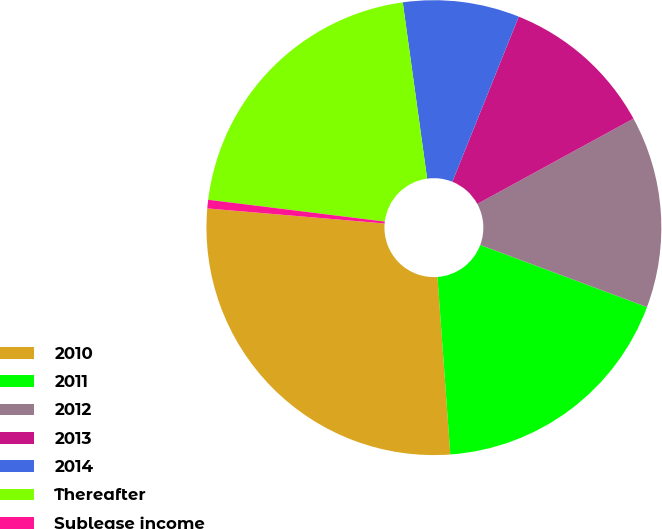Convert chart. <chart><loc_0><loc_0><loc_500><loc_500><pie_chart><fcel>2010<fcel>2011<fcel>2012<fcel>2013<fcel>2014<fcel>Thereafter<fcel>Sublease income<nl><fcel>27.5%<fcel>18.17%<fcel>13.64%<fcel>10.96%<fcel>8.27%<fcel>20.86%<fcel>0.61%<nl></chart> 